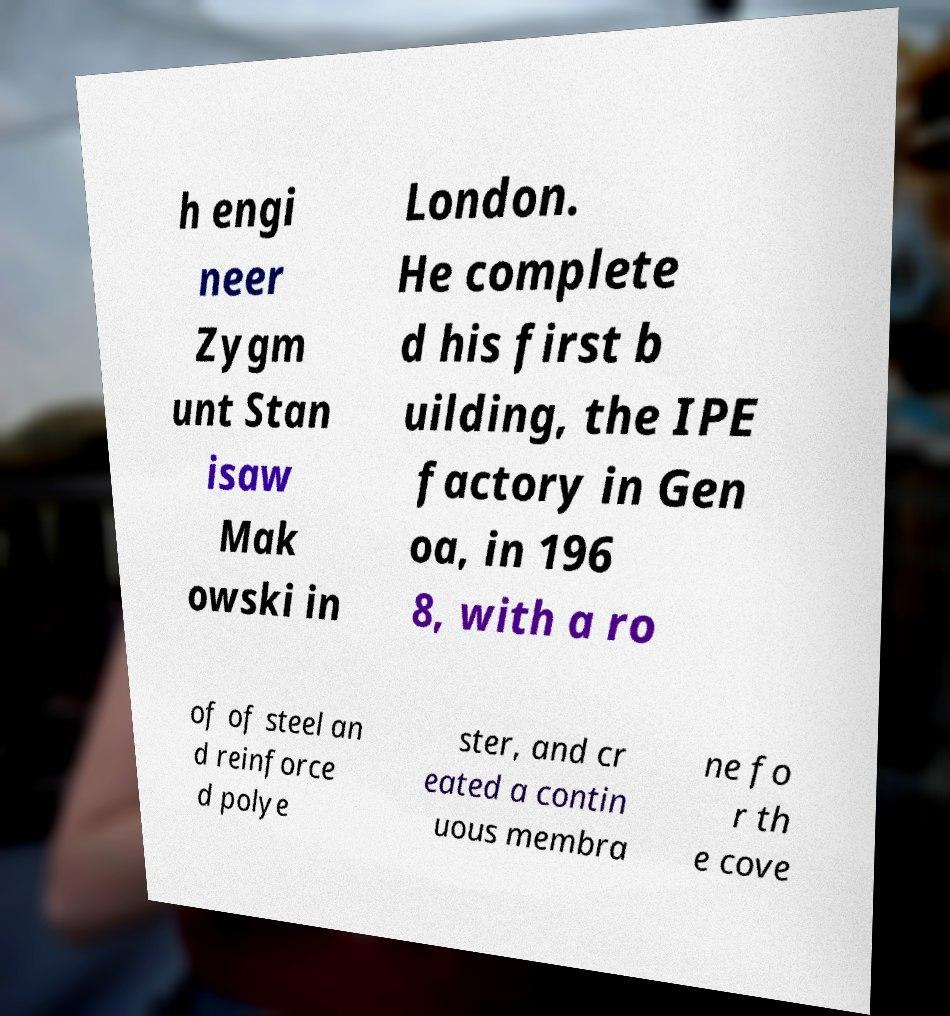I need the written content from this picture converted into text. Can you do that? h engi neer Zygm unt Stan isaw Mak owski in London. He complete d his first b uilding, the IPE factory in Gen oa, in 196 8, with a ro of of steel an d reinforce d polye ster, and cr eated a contin uous membra ne fo r th e cove 